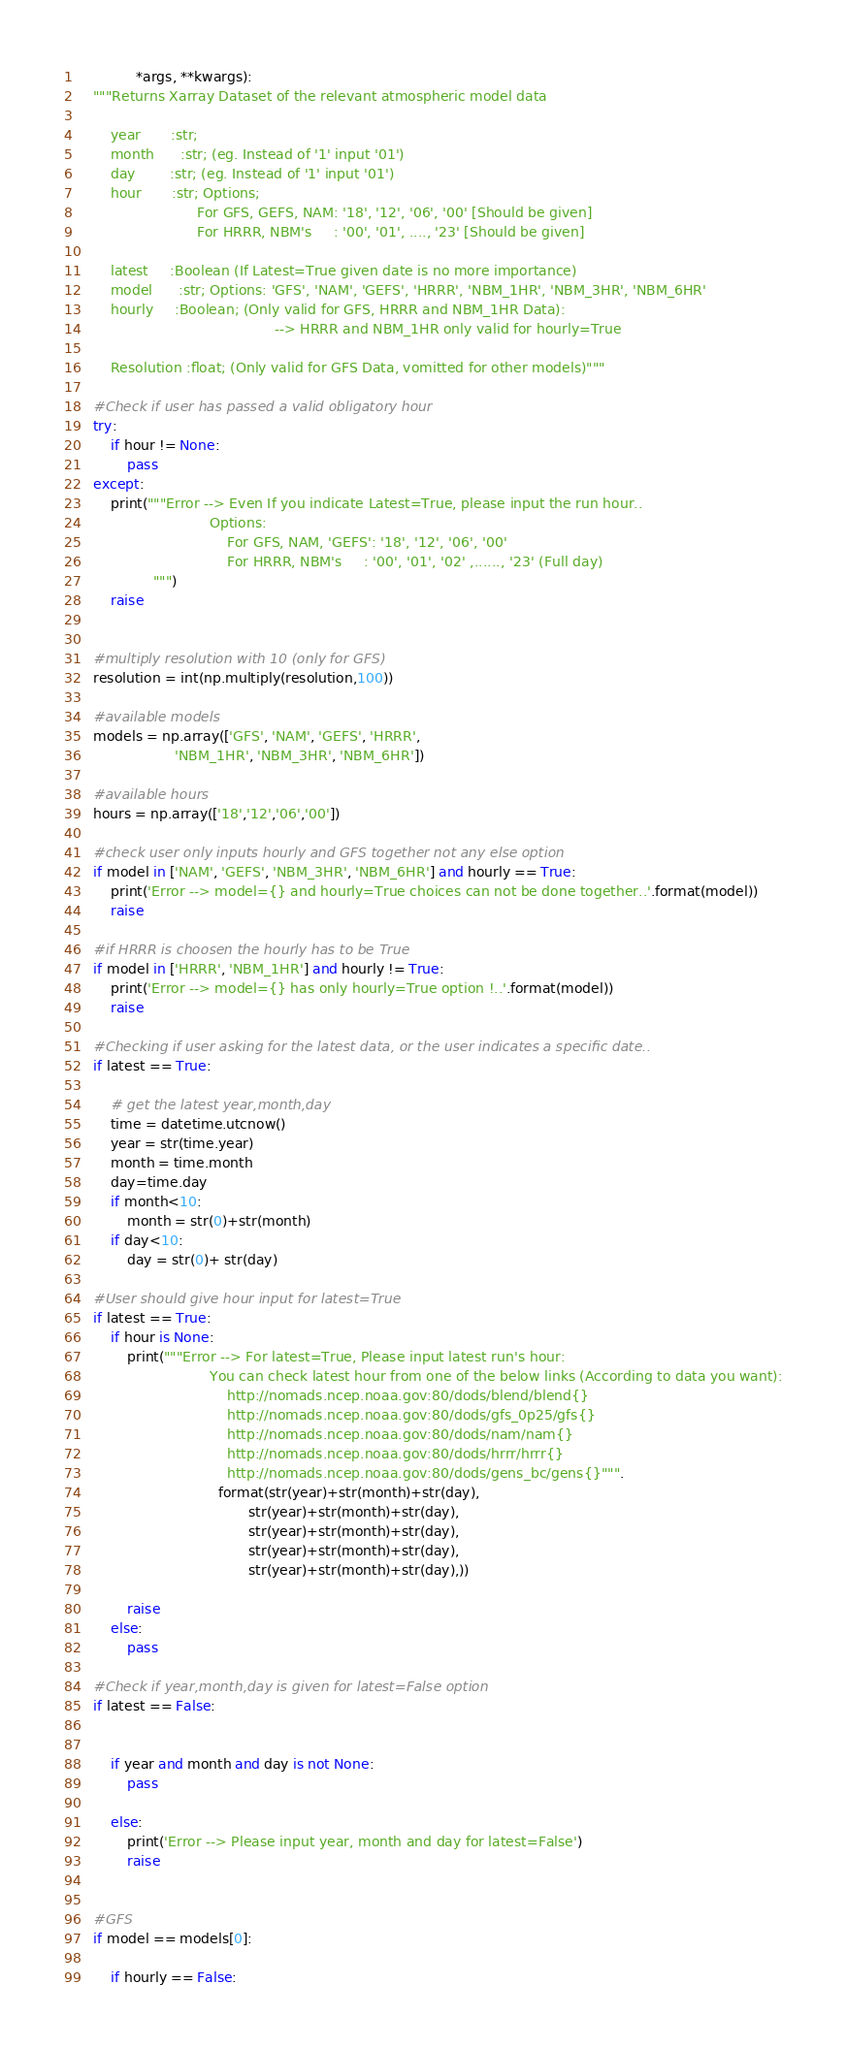<code> <loc_0><loc_0><loc_500><loc_500><_Python_>              *args, **kwargs):
    """Returns Xarray Dataset of the relevant atmospheric model data
    
        year       :str;
        month      :str; (eg. Instead of '1' input '01')
        day        :str; (eg. Instead of '1' input '01')
        hour       :str; Options;
                            For GFS, GEFS, NAM: '18', '12', '06', '00' [Should be given]
                            For HRRR, NBM's     : '00', '01', ...., '23' [Should be given]
                            
        latest     :Boolean (If Latest=True given date is no more importance)
        model      :str; Options: 'GFS', 'NAM', 'GEFS', 'HRRR', 'NBM_1HR', 'NBM_3HR', 'NBM_6HR' 
        hourly     :Boolean; (Only valid for GFS, HRRR and NBM_1HR Data):
                                              --> HRRR and NBM_1HR only valid for hourly=True
                                                
        Resolution :float; (Only valid for GFS Data, vomitted for other models)"""
    
    #Check if user has passed a valid obligatory hour
    try:
        if hour != None:
            pass
    except:
        print("""Error --> Even If you indicate Latest=True, please input the run hour..
                               Options:
                                   For GFS, NAM, 'GEFS': '18', '12', '06', '00'
                                   For HRRR, NBM's     : '00', '01', '02' ,......, '23' (Full day)
                  """)
        raise
            
    
    #multiply resolution with 10 (only for GFS)
    resolution = int(np.multiply(resolution,100))
    
    #available models
    models = np.array(['GFS', 'NAM', 'GEFS', 'HRRR',
                       'NBM_1HR', 'NBM_3HR', 'NBM_6HR'])
    
    #available hours
    hours = np.array(['18','12','06','00'])
    
    #check user only inputs hourly and GFS together not any else option 
    if model in ['NAM', 'GEFS', 'NBM_3HR', 'NBM_6HR'] and hourly == True:
        print('Error --> model={} and hourly=True choices can not be done together..'.format(model))
        raise
    
    #if HRRR is choosen the hourly has to be True
    if model in ['HRRR', 'NBM_1HR'] and hourly != True:
        print('Error --> model={} has only hourly=True option !..'.format(model))
        raise
    
    #Checking if user asking for the latest data, or the user indicates a specific date..
    if latest == True:
        
        # get the latest year,month,day
        time = datetime.utcnow()
        year = str(time.year)
        month = time.month
        day=time.day
        if month<10:
            month = str(0)+str(month)
        if day<10:
            day = str(0)+ str(day)
    
    #User should give hour input for latest=True
    if latest == True:
        if hour is None:
            print("""Error --> For latest=True, Please input latest run's hour:
                               You can check latest hour from one of the below links (According to data you want):
                                   http://nomads.ncep.noaa.gov:80/dods/blend/blend{}
                                   http://nomads.ncep.noaa.gov:80/dods/gfs_0p25/gfs{}
                                   http://nomads.ncep.noaa.gov:80/dods/nam/nam{}
                                   http://nomads.ncep.noaa.gov:80/dods/hrrr/hrrr{}
                                   http://nomads.ncep.noaa.gov:80/dods/gens_bc/gens{}""".
                                 format(str(year)+str(month)+str(day),
                                        str(year)+str(month)+str(day),
                                        str(year)+str(month)+str(day),
                                        str(year)+str(month)+str(day),
                                        str(year)+str(month)+str(day),))
                                                
            raise
        else:
            pass
    
    #Check if year,month,day is given for latest=False option
    if latest == False:
        
        
        if year and month and day is not None:
            pass
        
        else:
            print('Error --> Please input year, month and day for latest=False')
            raise
            
        
    #GFS
    if model == models[0]:
        
        if hourly == False:
</code> 